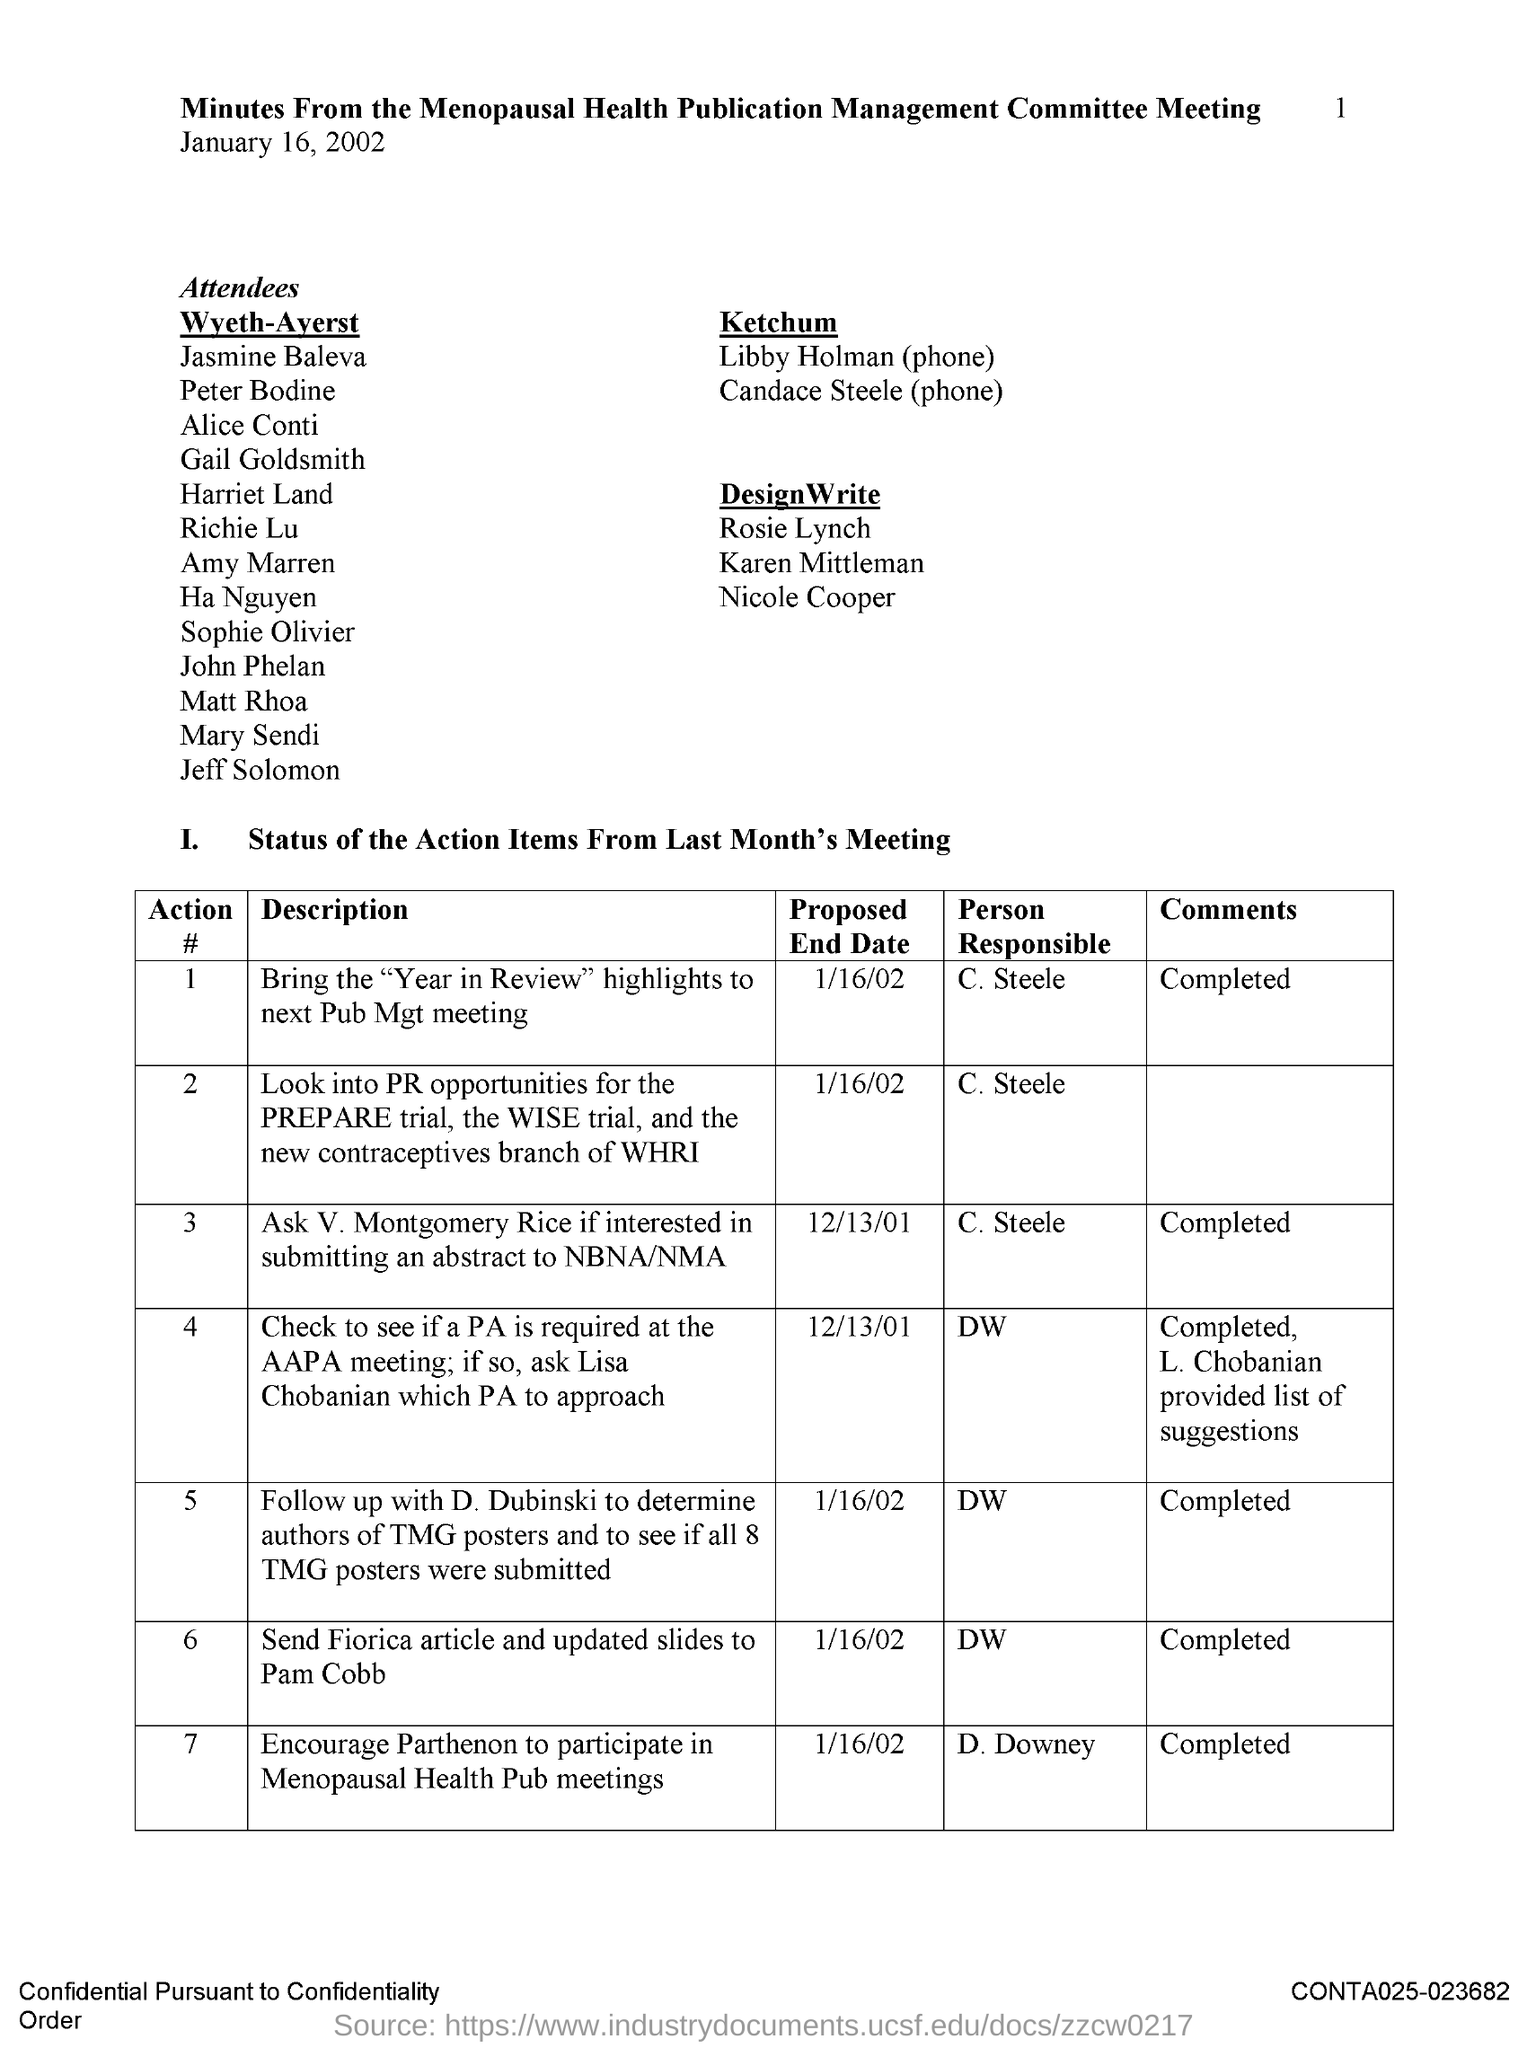Who is the person responsible to send Fiorica article and updated slides to Pam Cobb?
Give a very brief answer. DW. Who is the person responsible to bring the "Year in Review" highlights to next Pub Mgt meeting?
Offer a very short reply. C. Steele. What is the proposed end date to ask V. Montgomery Rice if interested in submitting an abstract to NBNA/NMA?
Offer a terse response. 12/13/01. Who is the person responsible to ask V. Montgomery Rice if interested in submitting an abstract to NBNA/NMA?
Offer a terse response. C. Steele. What is the proposed end date to send Fiorica article and updated slides to Pam Cobb?
Offer a terse response. 1/16/02. 